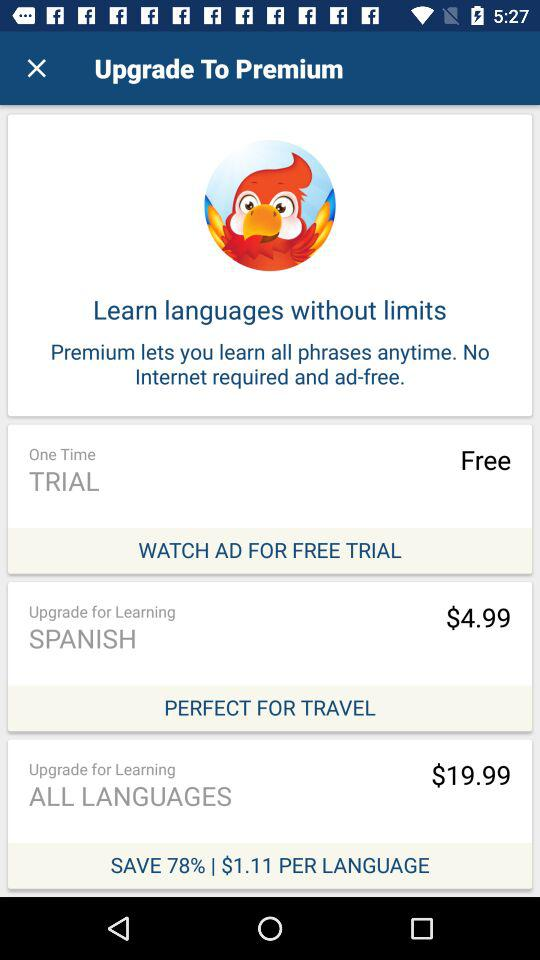On what option can we save 78%? You can save 78% on the "ALL LANGUAGES" option. 